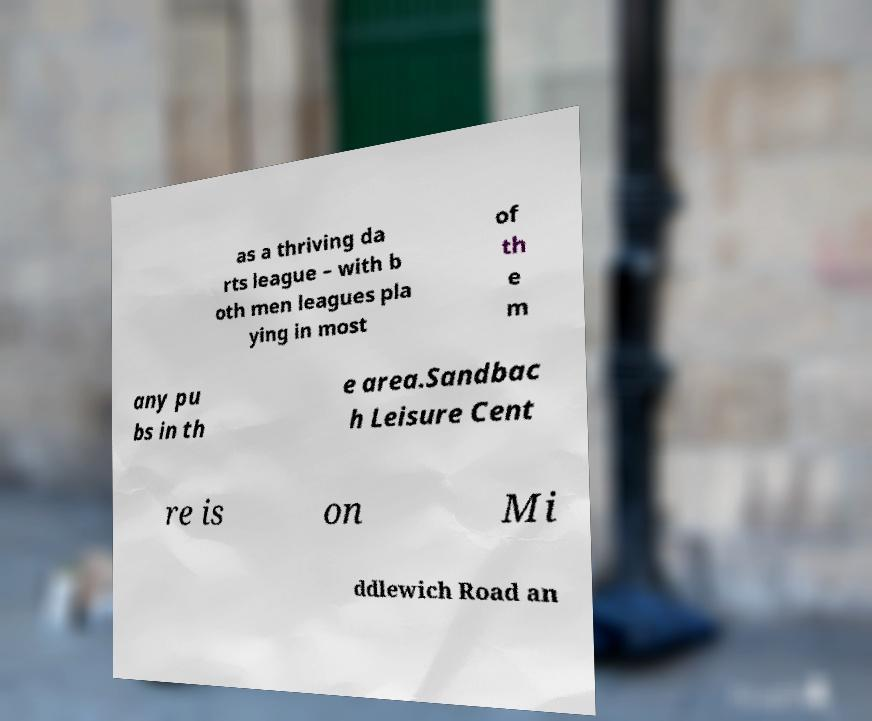For documentation purposes, I need the text within this image transcribed. Could you provide that? as a thriving da rts league – with b oth men leagues pla ying in most of th e m any pu bs in th e area.Sandbac h Leisure Cent re is on Mi ddlewich Road an 